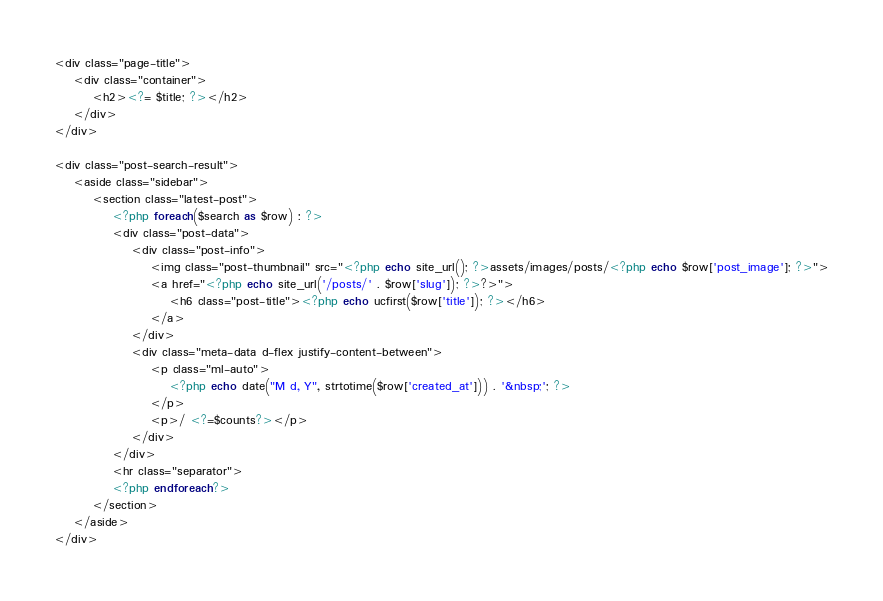<code> <loc_0><loc_0><loc_500><loc_500><_PHP_><div class="page-title">
    <div class="container">
        <h2><?= $title; ?></h2>
    </div>
</div>

<div class="post-search-result">
    <aside class="sidebar">
        <section class="latest-post">
            <?php foreach($search as $row) : ?>
            <div class="post-data">
                <div class="post-info">
                    <img class="post-thumbnail" src="<?php echo site_url(); ?>assets/images/posts/<?php echo $row['post_image']; ?>">
                    <a href="<?php echo site_url('/posts/' . $row['slug']); ?>?>">
                        <h6 class="post-title"><?php echo ucfirst($row['title']); ?></h6>
                    </a>
                </div>
                <div class="meta-data d-flex justify-content-between">
                    <p class="ml-auto">
                        <?php echo date("M d, Y", strtotime($row['created_at'])) . '&nbsp;'; ?>
                    </p>
                    <p>/ <?=$counts?></p>
                </div>
            </div>
            <hr class="separator">
            <?php endforeach?>
        </section>
    </aside>
</div></code> 